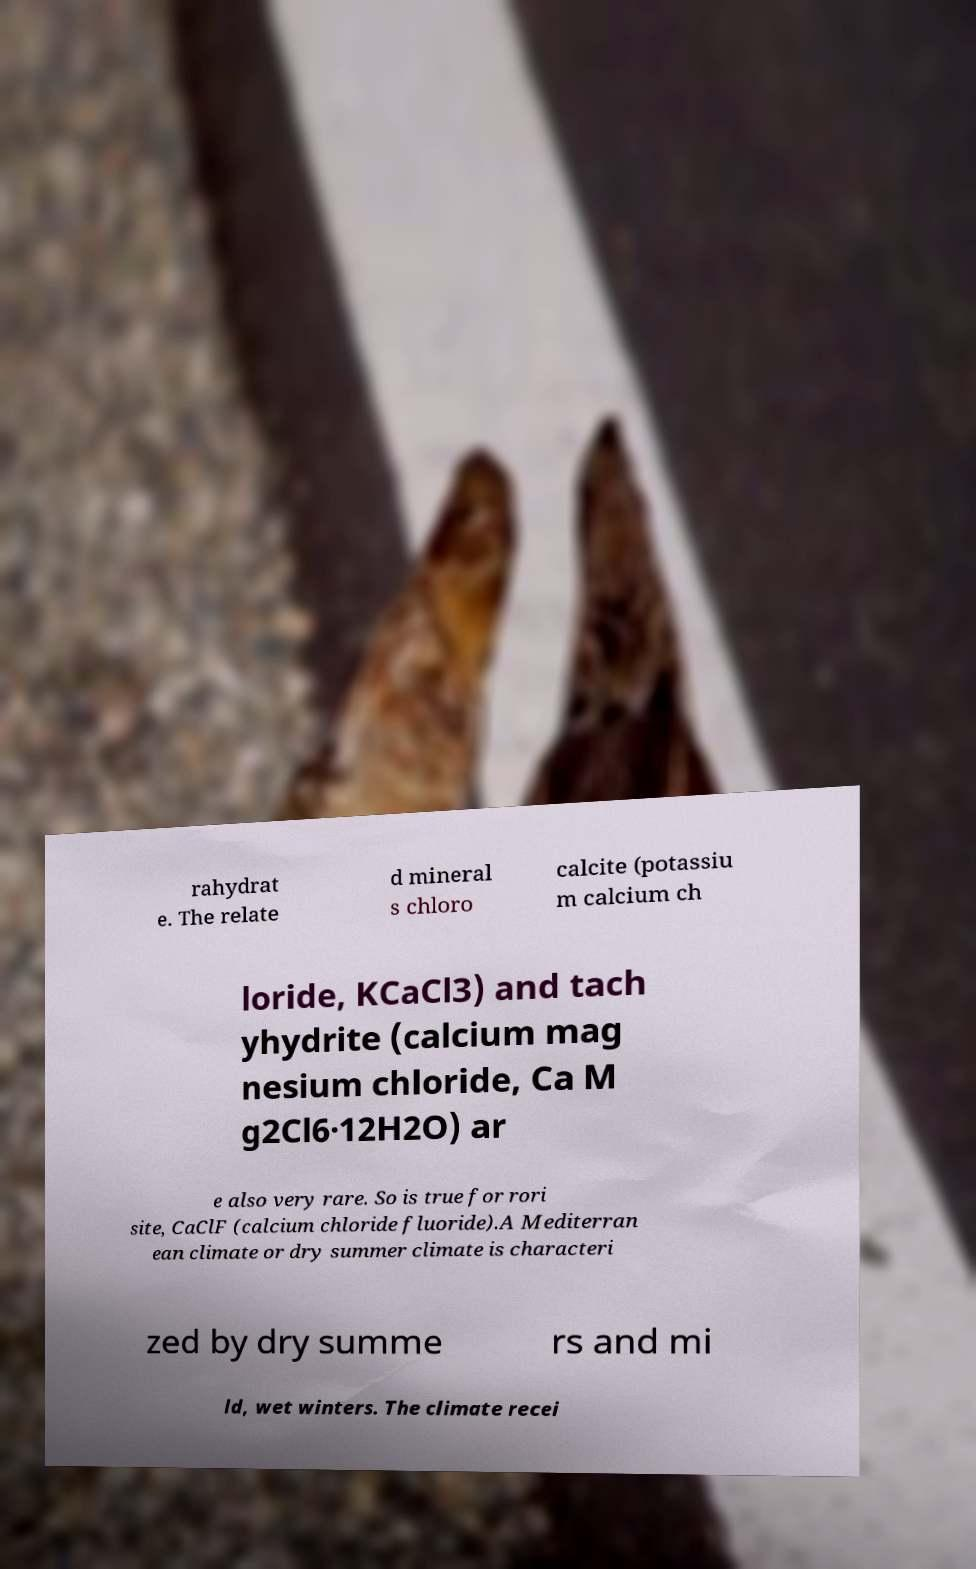I need the written content from this picture converted into text. Can you do that? rahydrat e. The relate d mineral s chloro calcite (potassiu m calcium ch loride, KCaCl3) and tach yhydrite (calcium mag nesium chloride, Ca M g2Cl6·12H2O) ar e also very rare. So is true for rori site, CaClF (calcium chloride fluoride).A Mediterran ean climate or dry summer climate is characteri zed by dry summe rs and mi ld, wet winters. The climate recei 